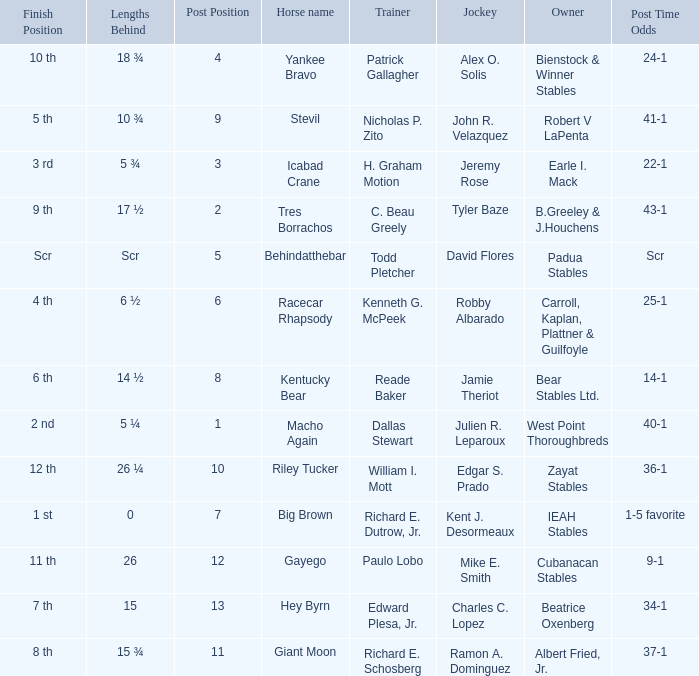What's the lengths behind of Jockey Ramon A. Dominguez? 15 ¾. 